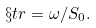Convert formula to latex. <formula><loc_0><loc_0><loc_500><loc_500>\S t r = \omega / S _ { 0 } .</formula> 